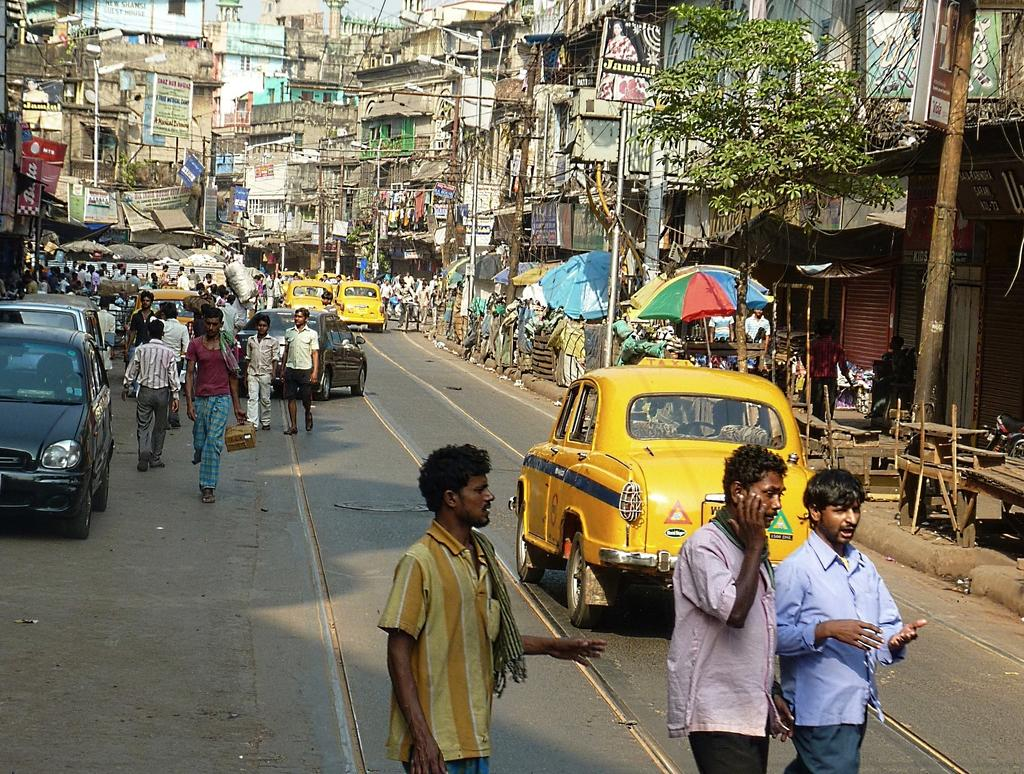What can be seen in the image involving people? There are people standing in the image. What is present on the road in the image? There are vehicles on the road in the image. What type of structures are visible in the image? There are poles, trees, and buildings in the image. What additional elements can be seen in the image? There are banners in the image. What type of texture can be seen on the bed in the image? There is no bed present in the image. How many buildings are visible in the image? The number of buildings cannot be determined from the provided facts, as it only states that there are buildings in the image. 